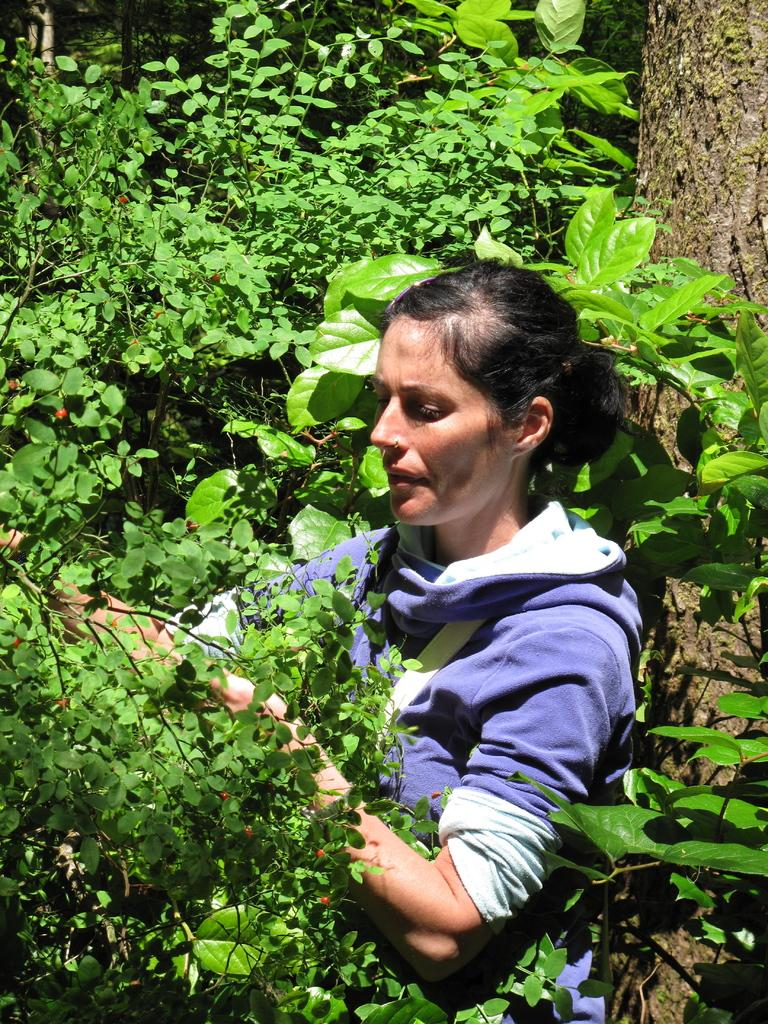Who is the main subject in the image? There is a woman in the image. What is the woman's position in relation to the tree? The woman is lying near the trunk of a tree. What type of vegetation is present around her? There are green leaves around her. What type of fruit is hanging from the tree in the image? There is no fruit visible in the image; only green leaves are present around the woman. 